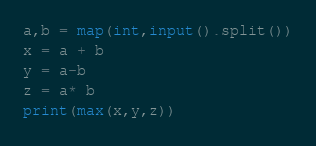Convert code to text. <code><loc_0><loc_0><loc_500><loc_500><_Python_>a,b = map(int,input().split())
x = a + b
y = a-b
z = a* b
print(max(x,y,z))</code> 